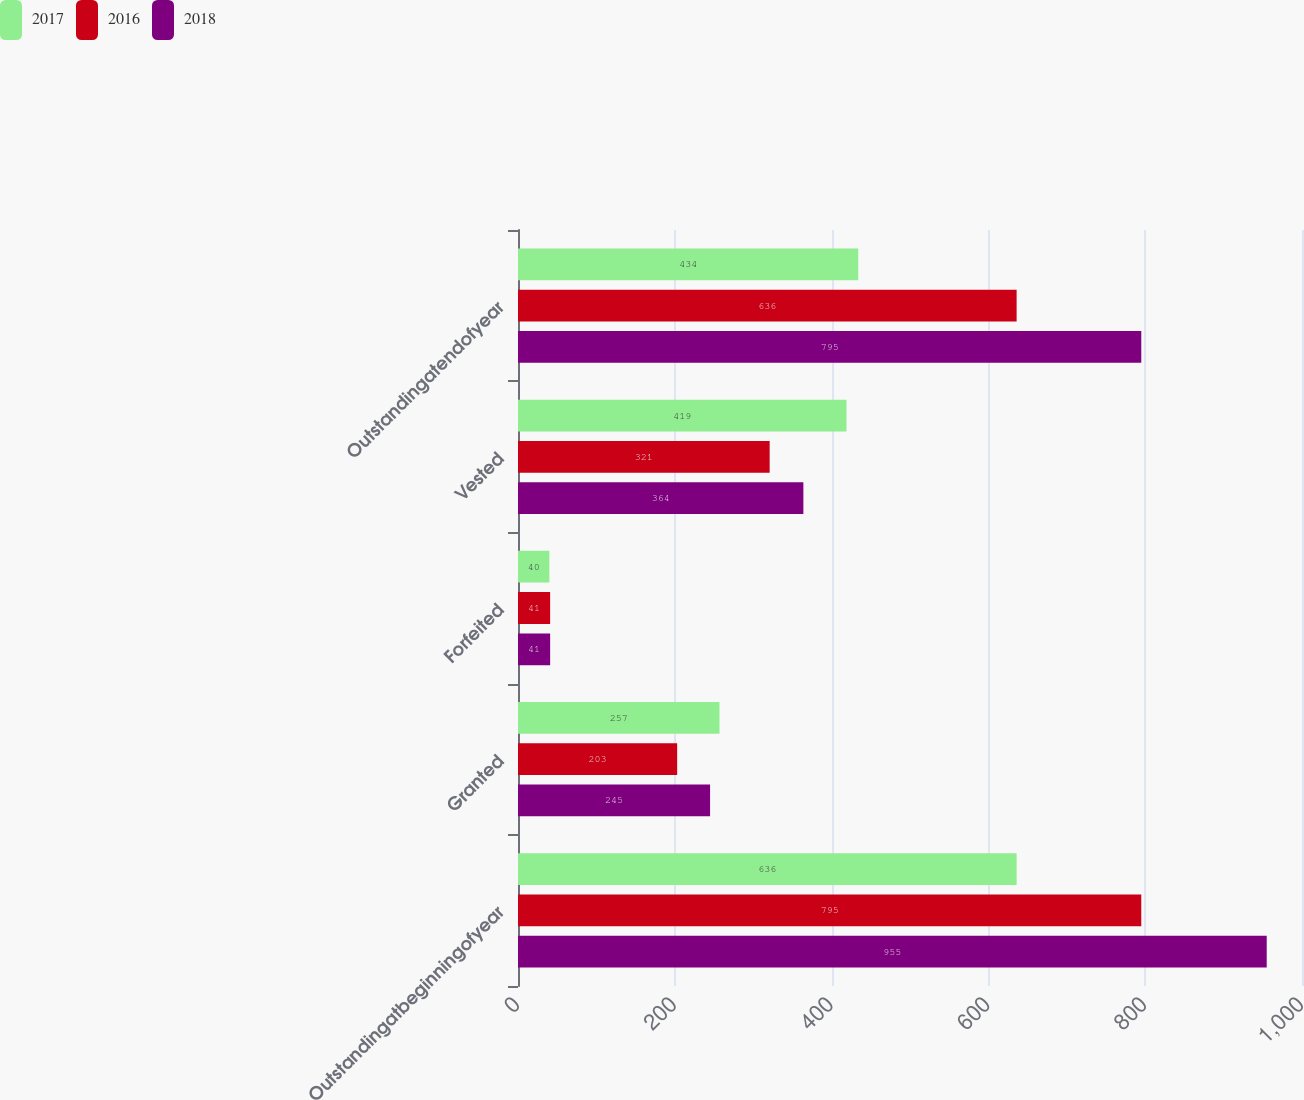<chart> <loc_0><loc_0><loc_500><loc_500><stacked_bar_chart><ecel><fcel>Outstandingatbeginningofyear<fcel>Granted<fcel>Forfeited<fcel>Vested<fcel>Outstandingatendofyear<nl><fcel>2017<fcel>636<fcel>257<fcel>40<fcel>419<fcel>434<nl><fcel>2016<fcel>795<fcel>203<fcel>41<fcel>321<fcel>636<nl><fcel>2018<fcel>955<fcel>245<fcel>41<fcel>364<fcel>795<nl></chart> 